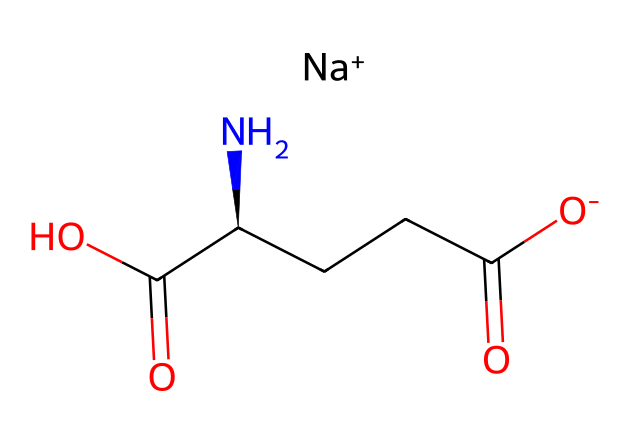What is the molecular formula of monosodium glutamate? By analyzing the SMILES representation, the number of carbon (C), hydrogen (H), nitrogen (N), oxygen (O), and sodium (Na) atoms can be counted: there are 5 carbons, 8 hydrogens, 1 nitrogen, 4 oxygens, and 1 sodium. Thus, the molecular formula is C5H8N1O4Na.
Answer: C5H8N1O4Na How many chiral centers are present in monosodium glutamate? The SMILES indicates the presence of the C[C@H](N) component, where the '@' symbol signifies a chiral center. There is one chiral center in the structure.
Answer: 1 What is the charge of the sodium ion in monosodium glutamate? The SMILES representation shows [Na+] indicating that the sodium ion has a +1 charge.
Answer: +1 Which functional groups are present in monosodium glutamate? Upon examining the structure, the molecule contains a carboxylic acid (-COOH) group, an amine (-NH2), and a sodium ion (Na+). Therefore, the functional groups present are carboxylic acid and amine.
Answer: carboxylic acid and amine What is the role of monosodium glutamate in food? Monosodium glutamate is primarily used as a flavor enhancer in processed foods, helping to enhance umami taste.
Answer: flavor enhancer How does monosodium glutamate affect taste perception? Monosodium glutamate amplifies the savory or umami flavor sensation on taste buds, making foods taste richer and more flavorful.
Answer: umami enhancement What is the primary source of monosodium glutamate? The primary source of monosodium glutamate is fermentation of sugar cane or molasses using specific bacteria, which convert sugars into glutamic acid, then neutralized with sodium.
Answer: fermentation of sugar cane 